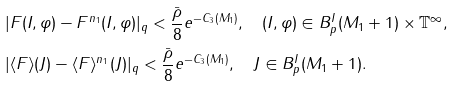Convert formula to latex. <formula><loc_0><loc_0><loc_500><loc_500>& | F ( I , \varphi ) - F ^ { n _ { 1 } } ( I , \varphi ) | _ { q } < \frac { \bar { \rho } } { 8 } e ^ { - C _ { 3 } ( M _ { 1 } ) } , \quad ( I , \varphi ) \in B ^ { I } _ { p } ( M _ { 1 } + 1 ) \times \mathbb { T } ^ { \infty } , \\ & | \langle F \rangle ( J ) - \langle F \rangle ^ { n _ { 1 } } ( J ) | _ { q } < \frac { \bar { \rho } } { 8 } e ^ { - C _ { 3 } ( M _ { 1 } ) } , \quad J \in B ^ { I } _ { p } ( M _ { 1 } + 1 ) .</formula> 